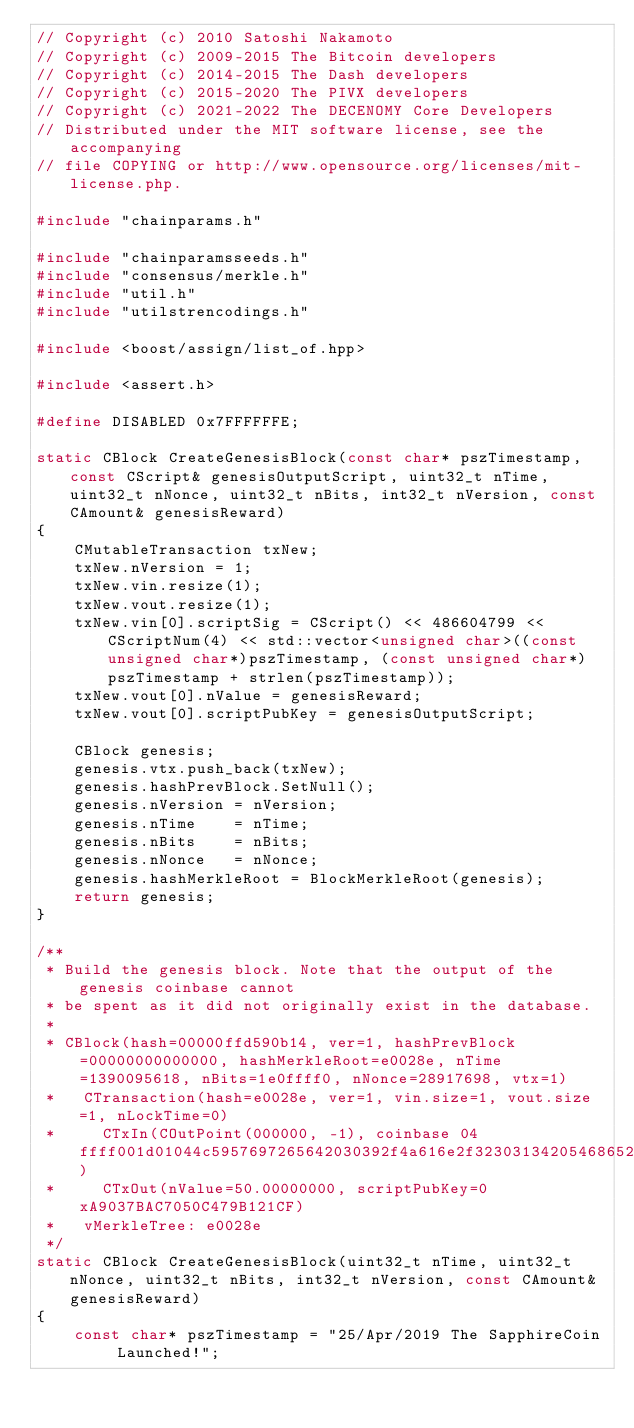<code> <loc_0><loc_0><loc_500><loc_500><_C++_>// Copyright (c) 2010 Satoshi Nakamoto
// Copyright (c) 2009-2015 The Bitcoin developers
// Copyright (c) 2014-2015 The Dash developers
// Copyright (c) 2015-2020 The PIVX developers
// Copyright (c) 2021-2022 The DECENOMY Core Developers
// Distributed under the MIT software license, see the accompanying
// file COPYING or http://www.opensource.org/licenses/mit-license.php.

#include "chainparams.h"

#include "chainparamsseeds.h"
#include "consensus/merkle.h"
#include "util.h"
#include "utilstrencodings.h"

#include <boost/assign/list_of.hpp>

#include <assert.h>

#define DISABLED 0x7FFFFFFE;

static CBlock CreateGenesisBlock(const char* pszTimestamp, const CScript& genesisOutputScript, uint32_t nTime, uint32_t nNonce, uint32_t nBits, int32_t nVersion, const CAmount& genesisReward)
{
    CMutableTransaction txNew;
    txNew.nVersion = 1;
    txNew.vin.resize(1);
    txNew.vout.resize(1);
    txNew.vin[0].scriptSig = CScript() << 486604799 << CScriptNum(4) << std::vector<unsigned char>((const unsigned char*)pszTimestamp, (const unsigned char*)pszTimestamp + strlen(pszTimestamp));
    txNew.vout[0].nValue = genesisReward;
    txNew.vout[0].scriptPubKey = genesisOutputScript;

    CBlock genesis;
    genesis.vtx.push_back(txNew);
    genesis.hashPrevBlock.SetNull();
    genesis.nVersion = nVersion;
    genesis.nTime    = nTime;
    genesis.nBits    = nBits;
    genesis.nNonce   = nNonce;
    genesis.hashMerkleRoot = BlockMerkleRoot(genesis);
    return genesis;
}

/**
 * Build the genesis block. Note that the output of the genesis coinbase cannot
 * be spent as it did not originally exist in the database.
 *
 * CBlock(hash=00000ffd590b14, ver=1, hashPrevBlock=00000000000000, hashMerkleRoot=e0028e, nTime=1390095618, nBits=1e0ffff0, nNonce=28917698, vtx=1)
 *   CTransaction(hash=e0028e, ver=1, vin.size=1, vout.size=1, nLockTime=0)
 *     CTxIn(COutPoint(000000, -1), coinbase 04ffff001d01044c5957697265642030392f4a616e2f3230313420546865204772616e64204578706572696d656e7420476f6573204c6976653a204f76657273746f636b2e636f6d204973204e6f7720416363657074696e6720426974636f696e73)
 *     CTxOut(nValue=50.00000000, scriptPubKey=0xA9037BAC7050C479B121CF)
 *   vMerkleTree: e0028e
 */
static CBlock CreateGenesisBlock(uint32_t nTime, uint32_t nNonce, uint32_t nBits, int32_t nVersion, const CAmount& genesisReward)
{
    const char* pszTimestamp = "25/Apr/2019 The SapphireCoin Launched!";</code> 